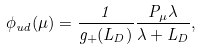Convert formula to latex. <formula><loc_0><loc_0><loc_500><loc_500>\phi _ { u d } ( \mu ) = \frac { 1 } { g _ { + } ( L _ { D } ) } \frac { P _ { \mu } \lambda } { \lambda + L _ { D } } ,</formula> 